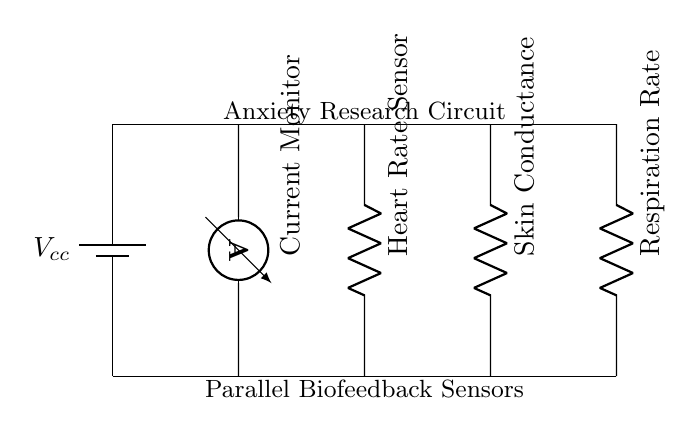What is represented by the label "Vcc"? "Vcc" denotes the positive supply voltage for the circuit, which provides the necessary power for all components. In the provided circuit diagram, it is shown as a battery symbol at the left.
Answer: positive supply voltage How many biofeedback sensors are included in this circuit? The circuit diagram includes three biofeedback sensors: the heart rate sensor, skin conductance sensor, and respiration rate sensor. Each is represented by a resistor symbol in the circuit.
Answer: three What type of circuit is depicted? The diagram clearly illustrates a parallel circuit, as indicated by multiple components connected across the same voltage supply without sharing any connections along their paths.
Answer: parallel What does the ammeter measure in this circuit? The ammeter, positioned vertically within the circuit, measures the total current flowing through the circuit, providing insight into the overall electrical activity from the sensors.
Answer: total current How are the sensors connected in relation to the supply voltage? Each sensor is connected in parallel to the supply voltage, allowing them to operate independently while receiving the same voltage from Vcc, maximizing their individual functionality and accuracy.
Answer: in parallel What does the "Current Monitor" label indicate? The "Current Monitor" label indicates the presence of an ammeter, which is specifically designed to measure the electric current flowing through the wires of the circuit, reflecting the activity of the sensors.
Answer: ammeter 